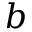Convert formula to latex. <formula><loc_0><loc_0><loc_500><loc_500>b</formula> 